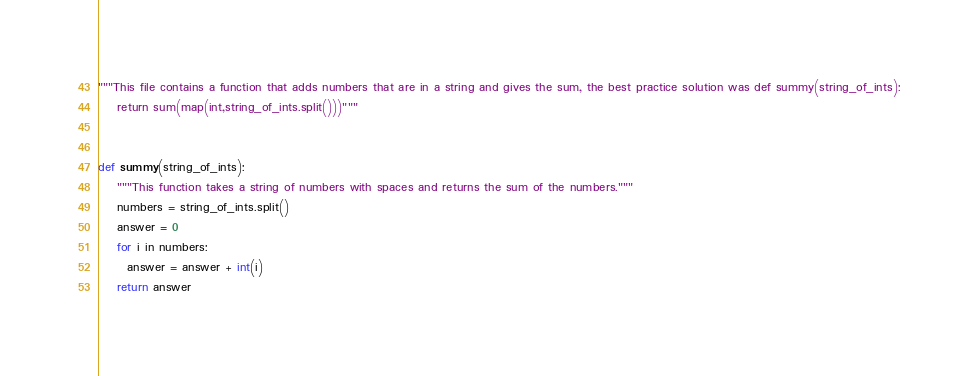Convert code to text. <code><loc_0><loc_0><loc_500><loc_500><_Python_>"""This file contains a function that adds numbers that are in a string and gives the sum, the best practice solution was def summy(string_of_ints):
    return sum(map(int,string_of_ints.split()))"""


def summy(string_of_ints):
    """This function takes a string of numbers with spaces and returns the sum of the numbers."""
    numbers = string_of_ints.split()
    answer = 0
    for i in numbers:
      answer = answer + int(i)
    return answer
</code> 